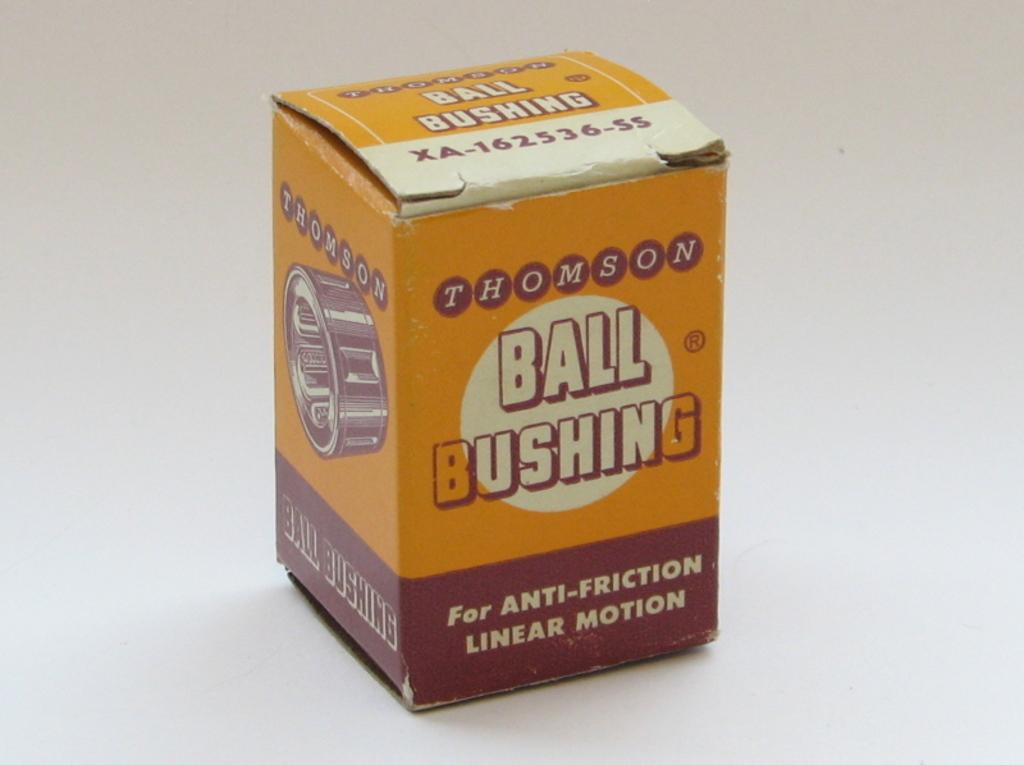Provide a one-sentence caption for the provided image. A Thomson Ball bushing for anti-friction linear motion. 